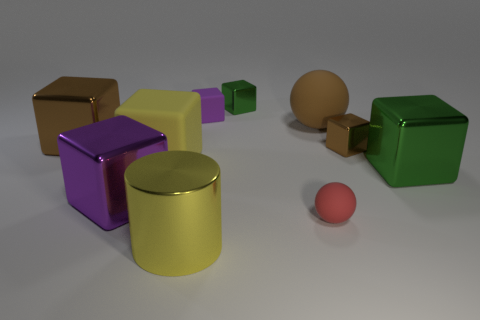How many objects are large purple metal things or cylinders?
Keep it short and to the point. 2. There is a green shiny cube on the right side of the red sphere; how big is it?
Provide a short and direct response. Large. There is a brown shiny cube to the right of the ball to the left of the brown rubber sphere; how many big yellow matte cubes are in front of it?
Provide a succinct answer. 1. Does the cylinder have the same color as the large matte cube?
Keep it short and to the point. Yes. What number of things are in front of the large brown ball and on the right side of the large yellow block?
Your response must be concise. 4. There is a purple thing to the left of the yellow matte thing; what is its shape?
Offer a terse response. Cube. Is the number of big cubes in front of the large yellow metallic object less than the number of metallic objects on the left side of the purple metallic block?
Provide a short and direct response. Yes. Is the material of the purple object that is on the right side of the big purple cube the same as the large sphere that is behind the tiny red ball?
Give a very brief answer. Yes. The tiny purple thing is what shape?
Give a very brief answer. Cube. Are there more large cylinders to the left of the large brown sphere than big green blocks to the left of the small brown metallic object?
Your answer should be compact. Yes. 